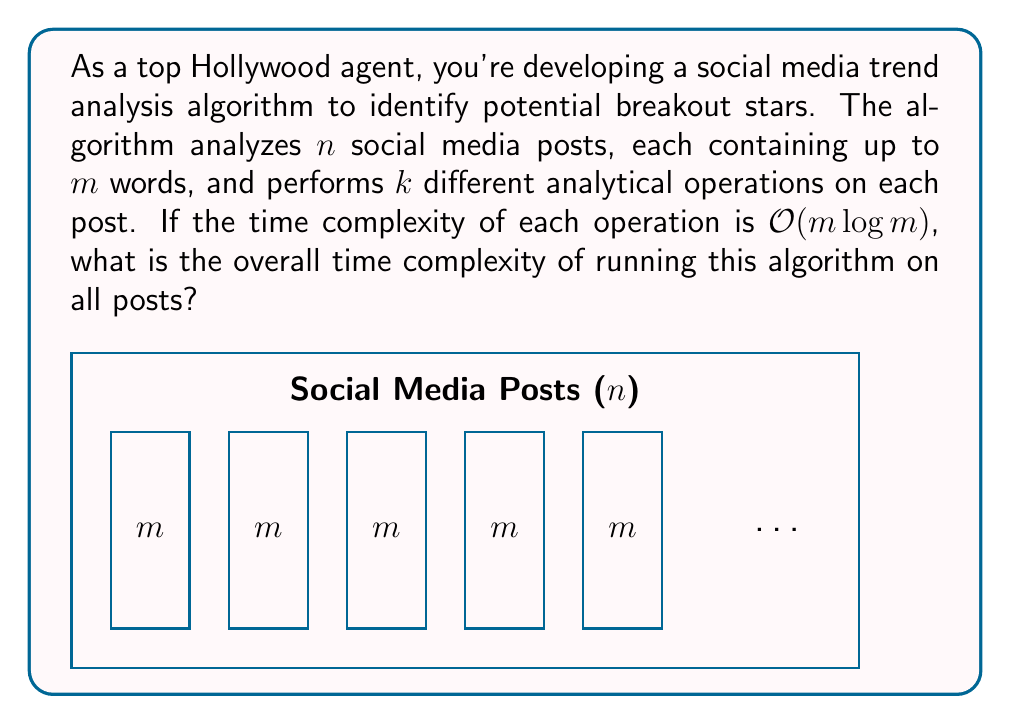Could you help me with this problem? Let's break this down step-by-step:

1) For each post, we perform $k$ different operations.

2) Each operation has a time complexity of $O(m \log m)$, where $m$ is the number of words in a post.

3) Therefore, for a single post, the time complexity is:

   $$O(k \cdot m \log m)$$

4) We perform this analysis on all $n$ posts.

5) Thus, the overall time complexity is:

   $$O(n \cdot k \cdot m \log m)$$

6) Since $k$ is a constant (the number of different analytical operations), we can simplify this to:

   $$O(n \cdot m \log m)$$

This represents the worst-case scenario where each post contains the maximum number of words $m$.
Answer: $O(n \cdot m \log m)$ 